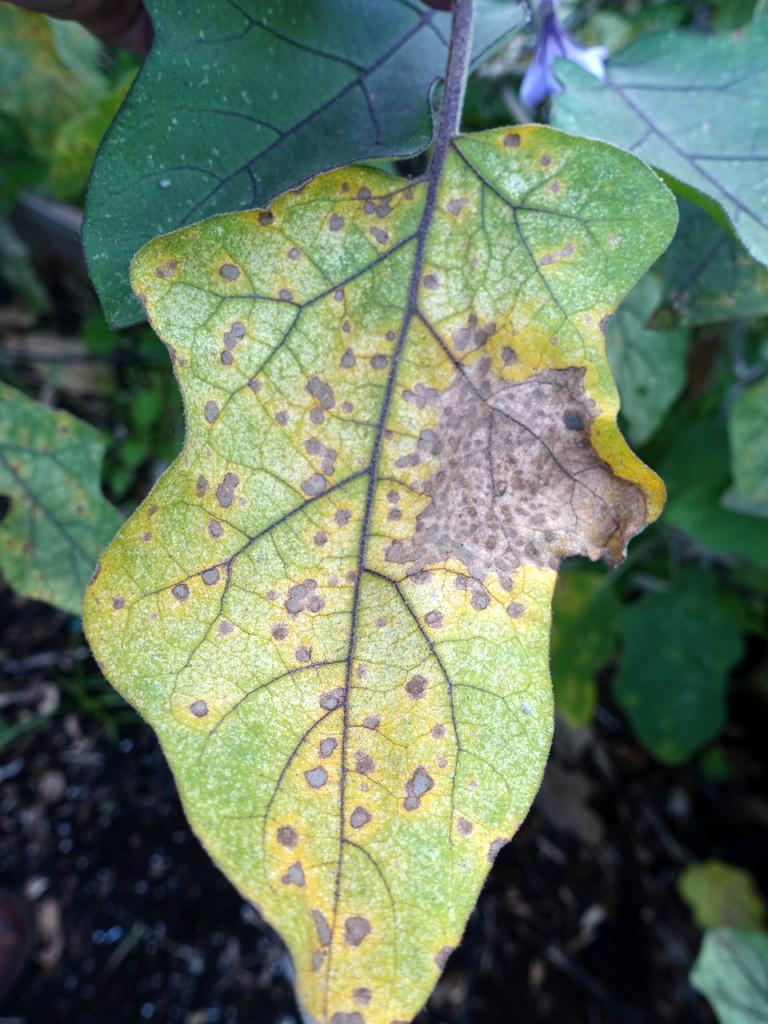What type of vegetation is visible in the image? There are green color leaves in the image. What type of linen can be seen being used for breakfast in the image? There is no linen or breakfast present in the image; it only features green color leaves. 